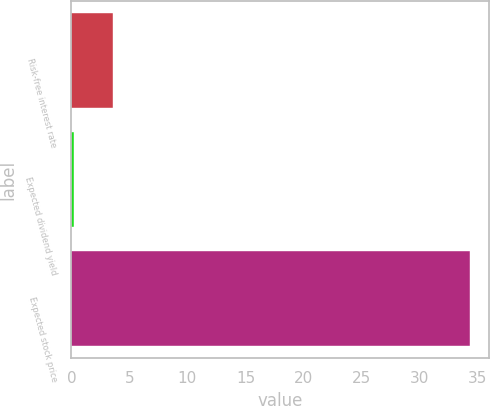Convert chart to OTSL. <chart><loc_0><loc_0><loc_500><loc_500><bar_chart><fcel>Risk-free interest rate<fcel>Expected dividend yield<fcel>Expected stock price<nl><fcel>3.61<fcel>0.2<fcel>34.3<nl></chart> 